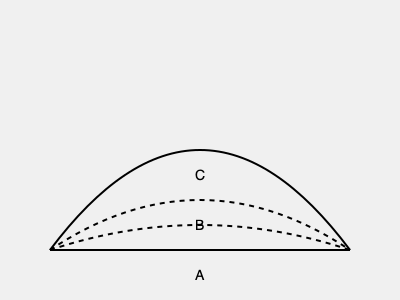Which of the cross-sections (A, B, or C) most accurately represents the typical profile of a Byzantine-style dome? To identify the correct cross-section of a Byzantine-style dome, we need to consider the following steps:

1. Byzantine architecture is characterized by its use of the pendentive dome, which allows a circular dome to be placed over a square base.

2. The profile of a Byzantine dome is typically described as "shallow" or "low-rise" compared to later Renaissance domes.

3. The cross-section of a Byzantine dome usually follows a segment of a circle, rather than a pointed arch or a flattened curve.

4. Looking at the provided options:
   A: This shows a semicircular profile, which is the most characteristic of Byzantine domes.
   B: This represents a shallower, flattened curve, which is less common in Byzantine architecture.
   C: This shows an even flatter profile, which is not typical of Byzantine domes.

5. The semicircular profile (A) allows for the most efficient distribution of weight and forces, which was a key consideration in Byzantine engineering.

6. This semicircular shape also provides the interior space with a sense of height and airiness, which was important for the spiritual atmosphere of Byzantine churches.

Therefore, the cross-section that most accurately represents the typical profile of a Byzantine-style dome is option A, the semicircular profile.
Answer: A 